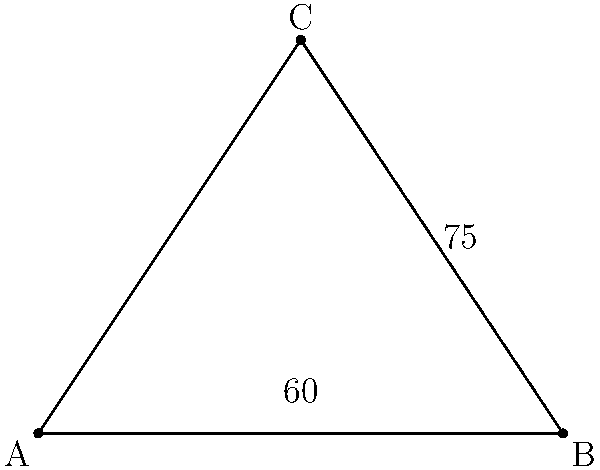In a medical setting, two IV drip lines are positioned to form a triangle with the patient's bed. The angle between the first drip line and the bed is 60°, while the angle between the second drip line and the bed is 75°. What is the angle between the two IV drip lines to ensure proper fluid flow? To find the angle between the two IV drip lines, we can follow these steps:

1. Recognize that the two IV drip lines and the bed form a triangle.

2. Recall that the sum of angles in a triangle is always 180°.

3. Let's call the angle we're looking for $x°$.

4. Set up an equation based on the fact that the sum of all angles in the triangle must equal 180°:
   $60° + 75° + x° = 180°$

5. Simplify the left side of the equation:
   $135° + x° = 180°$

6. Subtract 135° from both sides to isolate $x$:
   $x° = 180° - 135°$

7. Perform the subtraction:
   $x° = 45°$

Therefore, the angle between the two IV drip lines is 45°.
Answer: 45° 